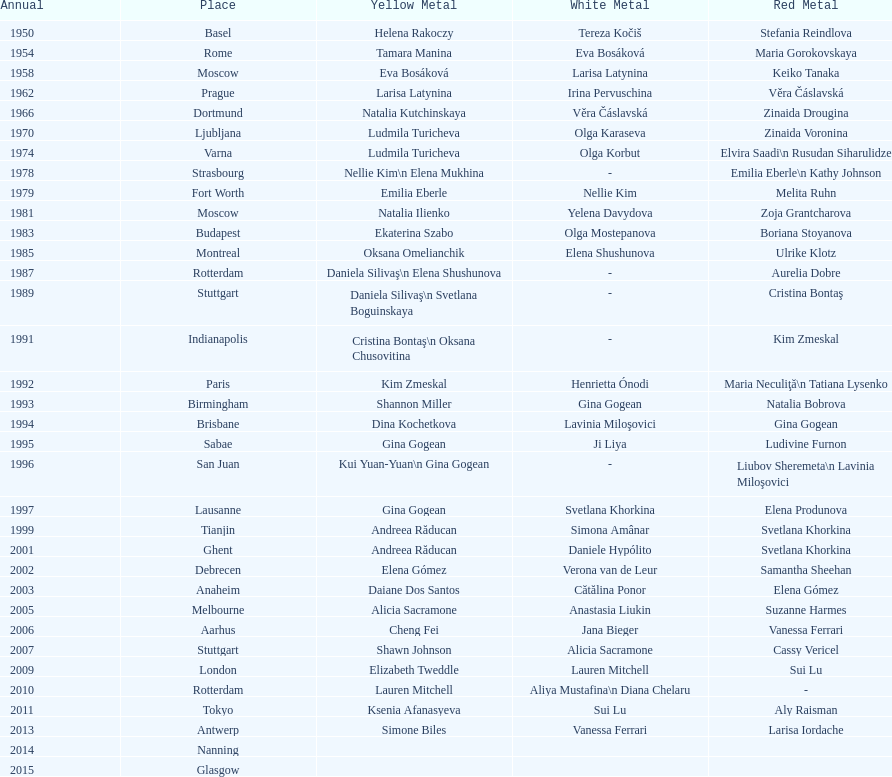What is the number of times a brazilian has won a medal? 2. 